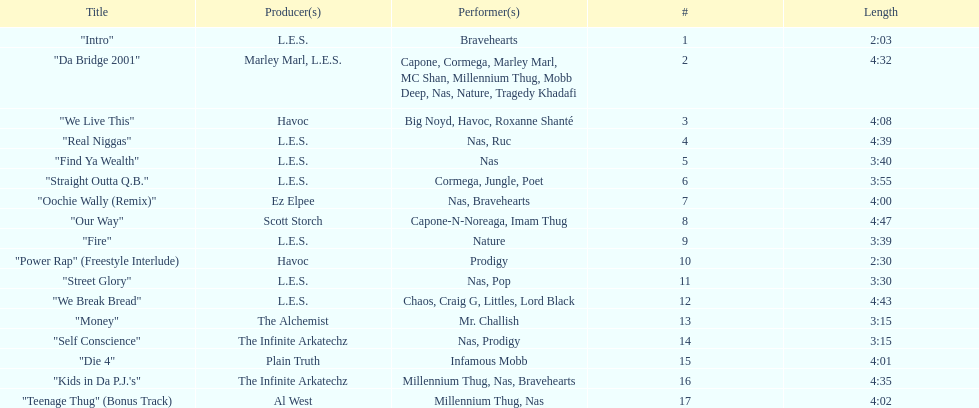What is the name of the last song on the album? "Teenage Thug" (Bonus Track). 